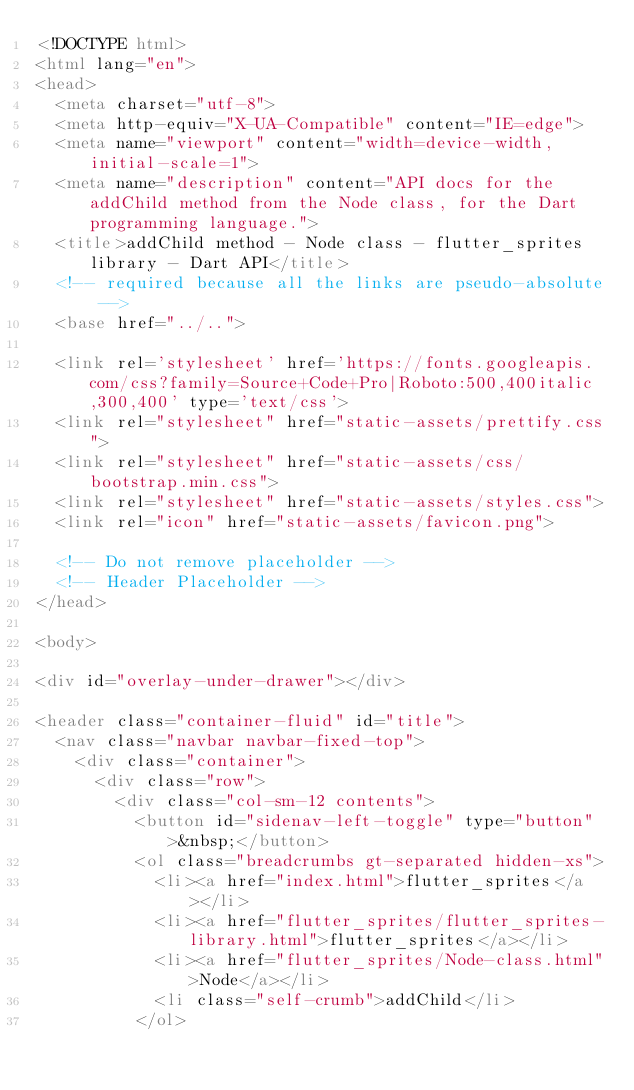<code> <loc_0><loc_0><loc_500><loc_500><_HTML_><!DOCTYPE html>
<html lang="en">
<head>
  <meta charset="utf-8">
  <meta http-equiv="X-UA-Compatible" content="IE=edge">
  <meta name="viewport" content="width=device-width, initial-scale=1">
  <meta name="description" content="API docs for the addChild method from the Node class, for the Dart programming language.">
  <title>addChild method - Node class - flutter_sprites library - Dart API</title>
  <!-- required because all the links are pseudo-absolute -->
  <base href="../..">

  <link rel='stylesheet' href='https://fonts.googleapis.com/css?family=Source+Code+Pro|Roboto:500,400italic,300,400' type='text/css'>
  <link rel="stylesheet" href="static-assets/prettify.css">
  <link rel="stylesheet" href="static-assets/css/bootstrap.min.css">
  <link rel="stylesheet" href="static-assets/styles.css">
  <link rel="icon" href="static-assets/favicon.png">

  <!-- Do not remove placeholder -->
  <!-- Header Placeholder -->
</head>

<body>

<div id="overlay-under-drawer"></div>

<header class="container-fluid" id="title">
  <nav class="navbar navbar-fixed-top">
    <div class="container">
      <div class="row">
        <div class="col-sm-12 contents">
          <button id="sidenav-left-toggle" type="button">&nbsp;</button>
          <ol class="breadcrumbs gt-separated hidden-xs">
            <li><a href="index.html">flutter_sprites</a></li>
            <li><a href="flutter_sprites/flutter_sprites-library.html">flutter_sprites</a></li>
            <li><a href="flutter_sprites/Node-class.html">Node</a></li>
            <li class="self-crumb">addChild</li>
          </ol></code> 